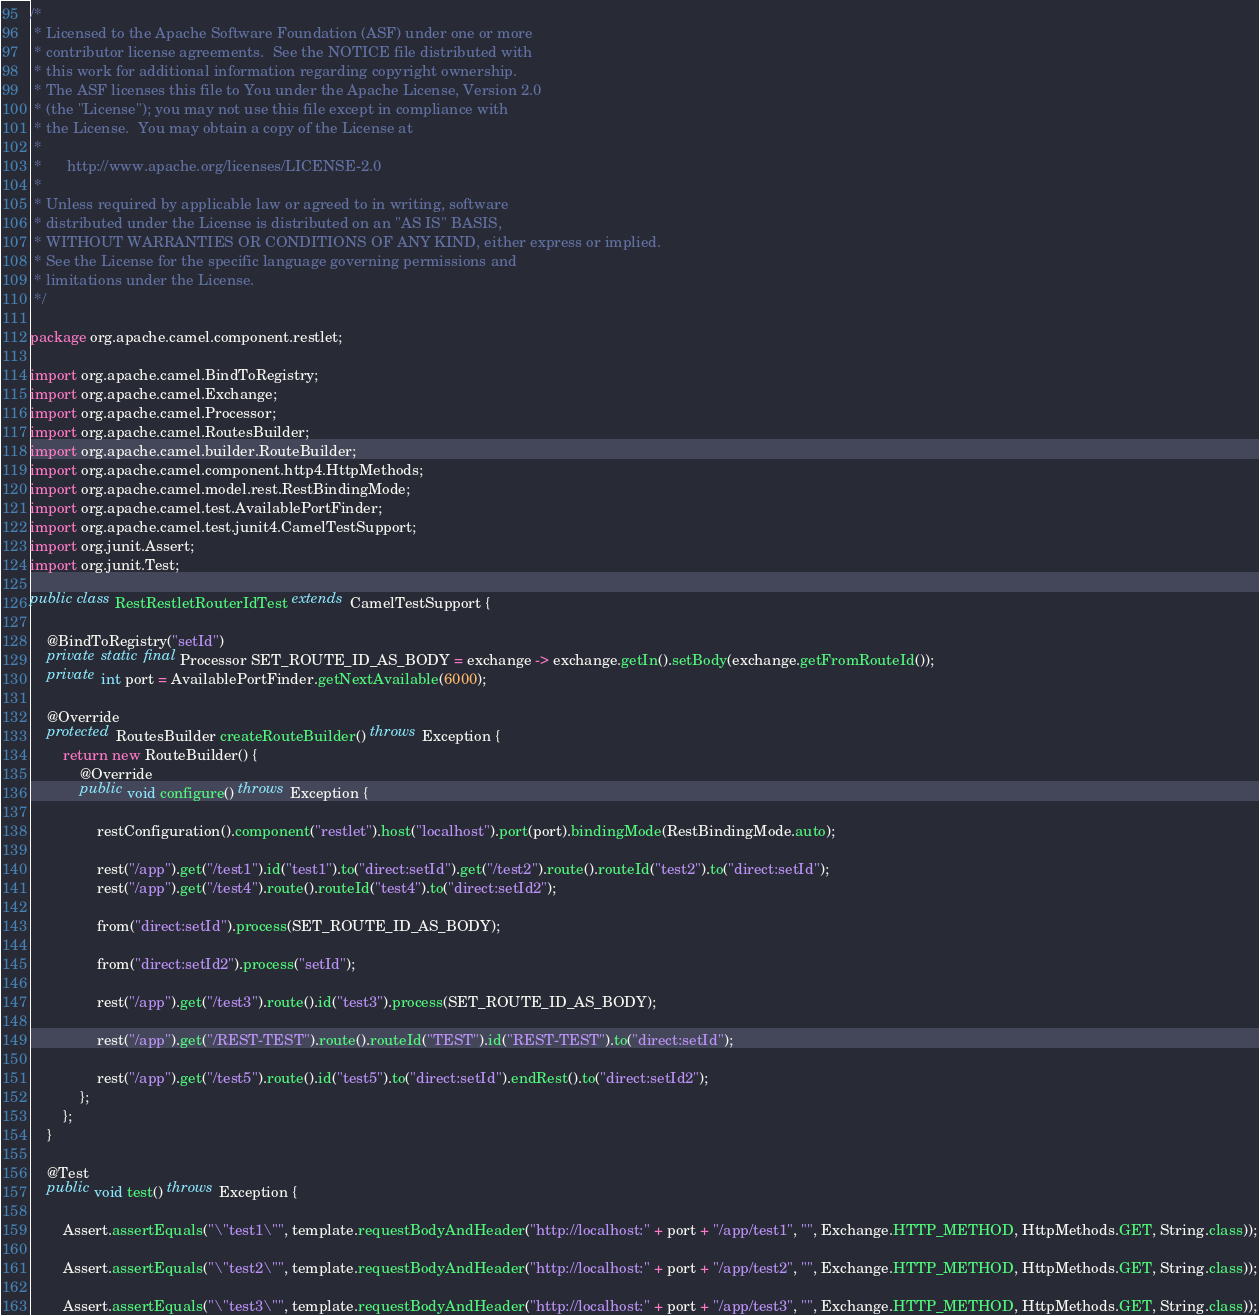Convert code to text. <code><loc_0><loc_0><loc_500><loc_500><_Java_>/*
 * Licensed to the Apache Software Foundation (ASF) under one or more
 * contributor license agreements.  See the NOTICE file distributed with
 * this work for additional information regarding copyright ownership.
 * The ASF licenses this file to You under the Apache License, Version 2.0
 * (the "License"); you may not use this file except in compliance with
 * the License.  You may obtain a copy of the License at
 *
 *      http://www.apache.org/licenses/LICENSE-2.0
 *
 * Unless required by applicable law or agreed to in writing, software
 * distributed under the License is distributed on an "AS IS" BASIS,
 * WITHOUT WARRANTIES OR CONDITIONS OF ANY KIND, either express or implied.
 * See the License for the specific language governing permissions and
 * limitations under the License.
 */

package org.apache.camel.component.restlet;

import org.apache.camel.BindToRegistry;
import org.apache.camel.Exchange;
import org.apache.camel.Processor;
import org.apache.camel.RoutesBuilder;
import org.apache.camel.builder.RouteBuilder;
import org.apache.camel.component.http4.HttpMethods;
import org.apache.camel.model.rest.RestBindingMode;
import org.apache.camel.test.AvailablePortFinder;
import org.apache.camel.test.junit4.CamelTestSupport;
import org.junit.Assert;
import org.junit.Test;

public class RestRestletRouterIdTest extends CamelTestSupport {

    @BindToRegistry("setId")
    private static final Processor SET_ROUTE_ID_AS_BODY = exchange -> exchange.getIn().setBody(exchange.getFromRouteId());
    private int port = AvailablePortFinder.getNextAvailable(6000);

    @Override
    protected RoutesBuilder createRouteBuilder() throws Exception {
        return new RouteBuilder() {
            @Override
            public void configure() throws Exception {

                restConfiguration().component("restlet").host("localhost").port(port).bindingMode(RestBindingMode.auto);

                rest("/app").get("/test1").id("test1").to("direct:setId").get("/test2").route().routeId("test2").to("direct:setId");
                rest("/app").get("/test4").route().routeId("test4").to("direct:setId2");

                from("direct:setId").process(SET_ROUTE_ID_AS_BODY);

                from("direct:setId2").process("setId");

                rest("/app").get("/test3").route().id("test3").process(SET_ROUTE_ID_AS_BODY);

                rest("/app").get("/REST-TEST").route().routeId("TEST").id("REST-TEST").to("direct:setId");

                rest("/app").get("/test5").route().id("test5").to("direct:setId").endRest().to("direct:setId2");
            };
        };
    }

    @Test
    public void test() throws Exception {

        Assert.assertEquals("\"test1\"", template.requestBodyAndHeader("http://localhost:" + port + "/app/test1", "", Exchange.HTTP_METHOD, HttpMethods.GET, String.class));

        Assert.assertEquals("\"test2\"", template.requestBodyAndHeader("http://localhost:" + port + "/app/test2", "", Exchange.HTTP_METHOD, HttpMethods.GET, String.class));

        Assert.assertEquals("\"test3\"", template.requestBodyAndHeader("http://localhost:" + port + "/app/test3", "", Exchange.HTTP_METHOD, HttpMethods.GET, String.class));
</code> 